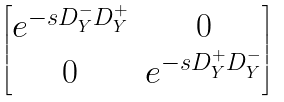Convert formula to latex. <formula><loc_0><loc_0><loc_500><loc_500>\begin{bmatrix} e ^ { - s D _ { Y } ^ { - } D _ { Y } ^ { + } } & 0 \\ 0 & e ^ { - s D _ { Y } ^ { + } D _ { Y } ^ { - } } \end{bmatrix}</formula> 